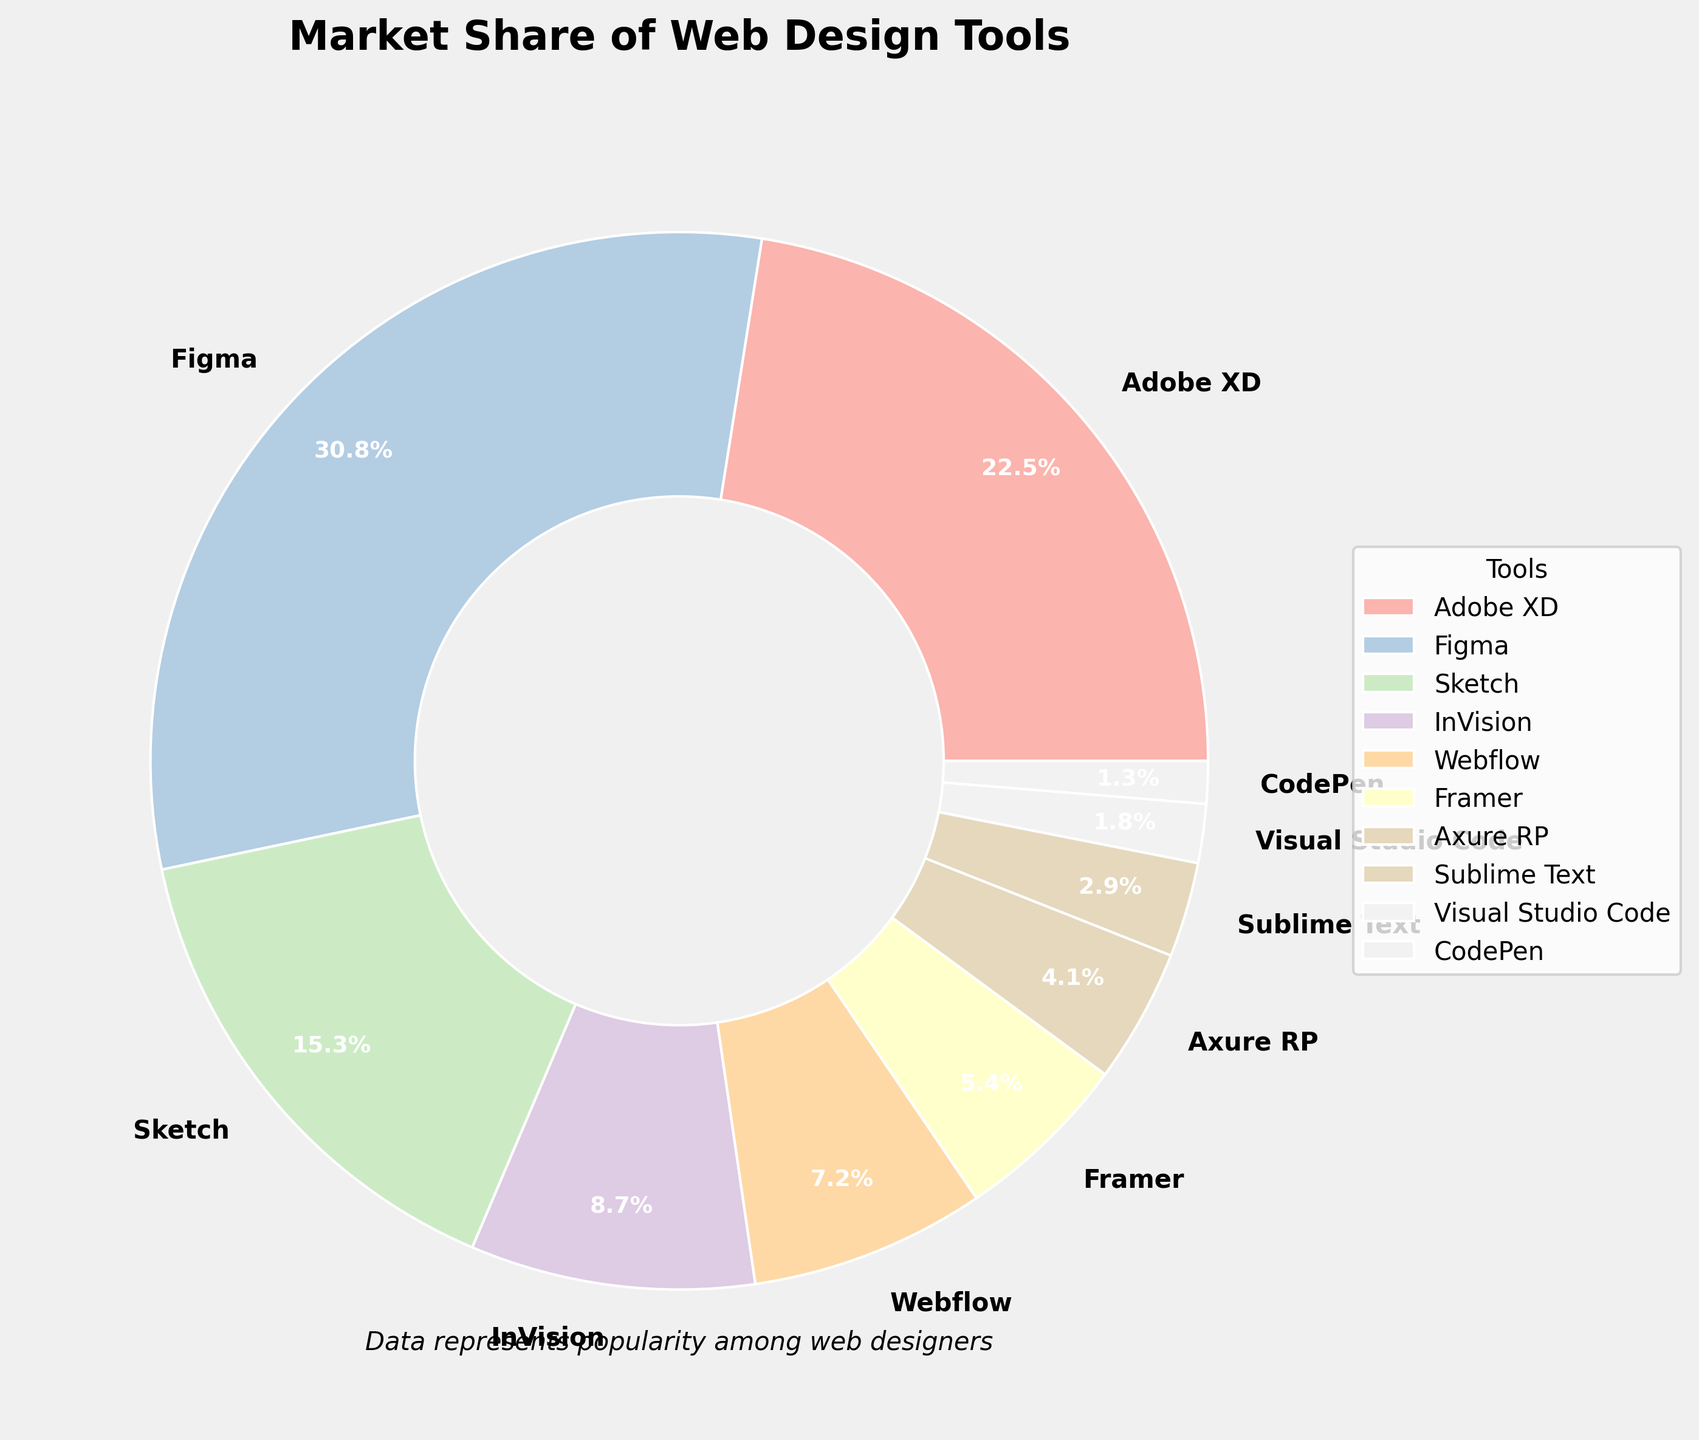Which tool has the largest market share? From the pie chart, Figma's segment is the largest. Figma has a market share of 30.8%.
Answer: Figma Which tool has a smaller market share, Sketch or InVision? Comparing the segments for Sketch and InVision, Sketch has a market share of 15.3% while InVision has 8.7%. Thus, InVision has a smaller market share.
Answer: InVision What is the combined market share of Webflow and Framer? According to the pie chart, Webflow has a market share of 7.2% and Framer has 5.4%. Combining them, 7.2% + 5.4% = 12.6%.
Answer: 12.6% Which tool's market share is closest to 10%? From the pie chart, InVision has a market share of 8.7%, which is the closest to 10%.
Answer: InVision Is the market share of Adobe XD more than double that of Axure RP? Adobe XD's market share is 22.5%, and Axure RP's market share is 4.1%. Since 22.5% is more than double 4.1% (which would be 8.2%), the statement is true.
Answer: Yes Which tool has the smallest market share? From the pie chart, CodePen has the smallest segment, with a market share of 1.3%.
Answer: CodePen How much more is the market share of Figma than that of Sublime Text? Figma has a market share of 30.8% and Sublime Text has 2.9%. Subtracting these, 30.8% - 2.9% = 27.9%.
Answer: 27.9% What is the total market share of the tools excluding Figma and Adobe XD? Summing the market shares of all tools except Figma (30.8%) and Adobe XD (22.5%) gives 100% - 30.8% - 22.5% = 46.7%.
Answer: 46.7% Which tool's segment color is visually the darkest? Referring to the pie chart's color scheme, the segment for Sublime Text appears to be the darkest shade used.
Answer: Sublime Text What is the average market share of InVision, Webflow, and Framer? Market shares are InVision 8.7%, Webflow 7.2%, and Framer 5.4%. Their sum is 8.7% + 7.2% + 5.4% = 21.3%. The average is 21.3% / 3 = 7.1%.
Answer: 7.1% 